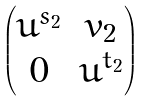Convert formula to latex. <formula><loc_0><loc_0><loc_500><loc_500>\begin{pmatrix} u ^ { s _ { 2 } } & v _ { 2 } \\ 0 & u ^ { t _ { 2 } } \end{pmatrix}</formula> 